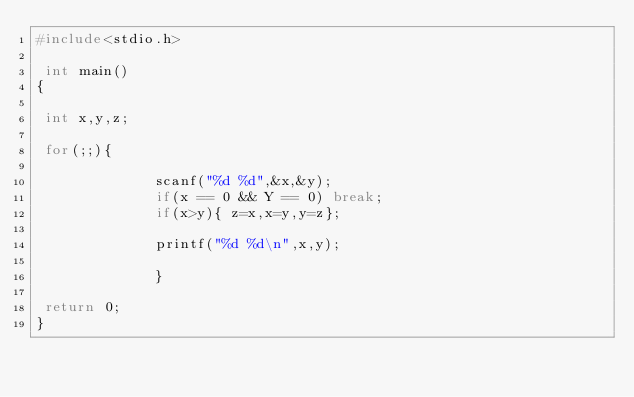Convert code to text. <code><loc_0><loc_0><loc_500><loc_500><_C_>#include<stdio.h>

 int main()
{

 int x,y,z;
 
 for(;;){

              scanf("%d %d",&x,&y);
              if(x == 0 && Y == 0) break;
              if(x>y){ z=x,x=y,y=z};

              printf("%d %d\n",x,y);

              }

 return 0;
}
 

</code> 